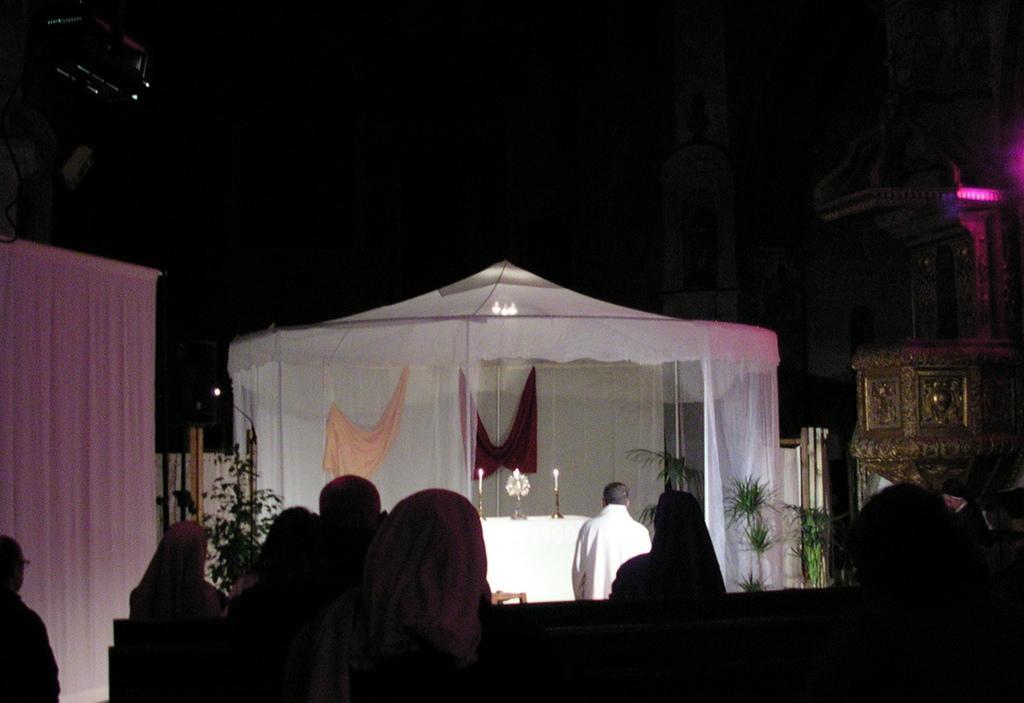Please provide a concise description of this image. In this picture we can see there are a group of people and in front of the people there is a tent and in the tent there are candles and other things. Behind the text there is a dark background. 